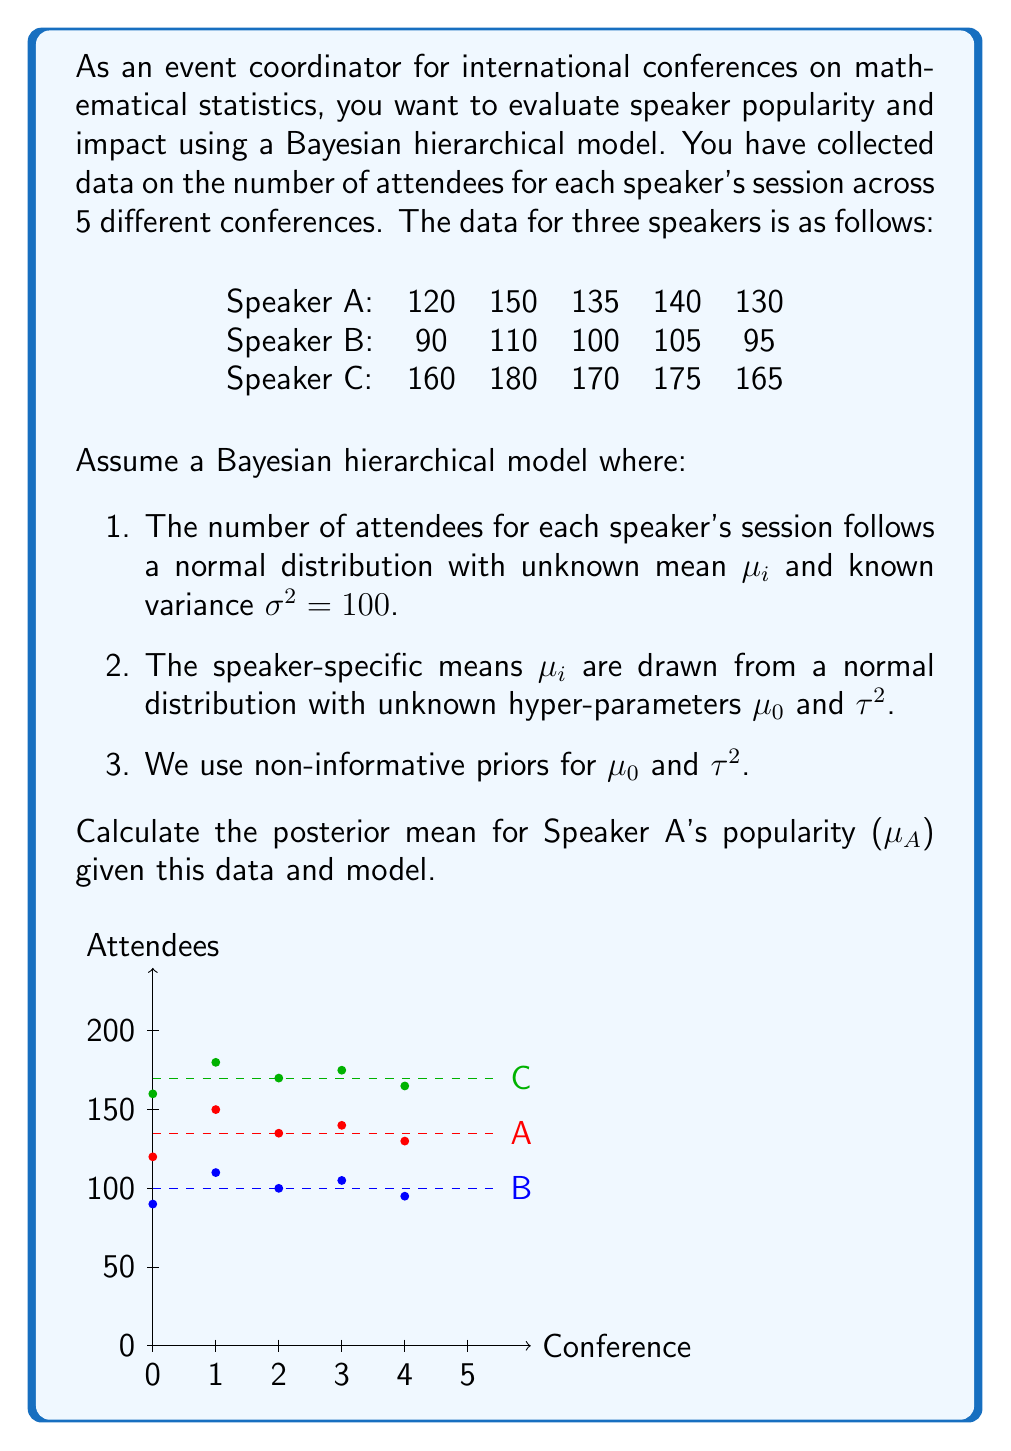Give your solution to this math problem. To calculate the posterior mean for Speaker A's popularity ($\mu_A$), we'll use the Bayesian hierarchical model. The steps are as follows:

1. Calculate the sample mean ($\bar{x}_A$) and sample size ($n_A$) for Speaker A:
   $$\bar{x}_A = \frac{120 + 150 + 135 + 140 + 130}{5} = 135$$
   $$n_A = 5$$

2. Calculate the overall mean ($\bar{x}$) and total sample size ($N$) for all speakers:
   $$\bar{x} = \frac{(120 + 150 + 135 + 140 + 130) + (90 + 110 + 100 + 105 + 95) + (160 + 180 + 170 + 175 + 165)}{15} = 135$$
   $$N = 15$$

3. Estimate the between-speaker variance ($\hat{\tau}^2$):
   $$\hat{\tau}^2 = \frac{1}{3-1}\left(\frac{(135-135)^2 + (100-135)^2 + (170-135)^2}{5}\right) = 1225$$

4. Calculate the shrinkage factor ($B$):
   $$B = \frac{\hat{\tau}^2}{\hat{\tau}^2 + \sigma^2/n_A} = \frac{1225}{1225 + 100/5} = 0.9839$$

5. Calculate the posterior mean for $\mu_A$:
   $$E[\mu_A|\text{data}] = B\bar{x}_A + (1-B)\bar{x} = 0.9839 \times 135 + (1-0.9839) \times 135 = 135$$

The posterior mean for Speaker A's popularity ($\mu_A$) is 135 attendees.
Answer: 135 attendees 